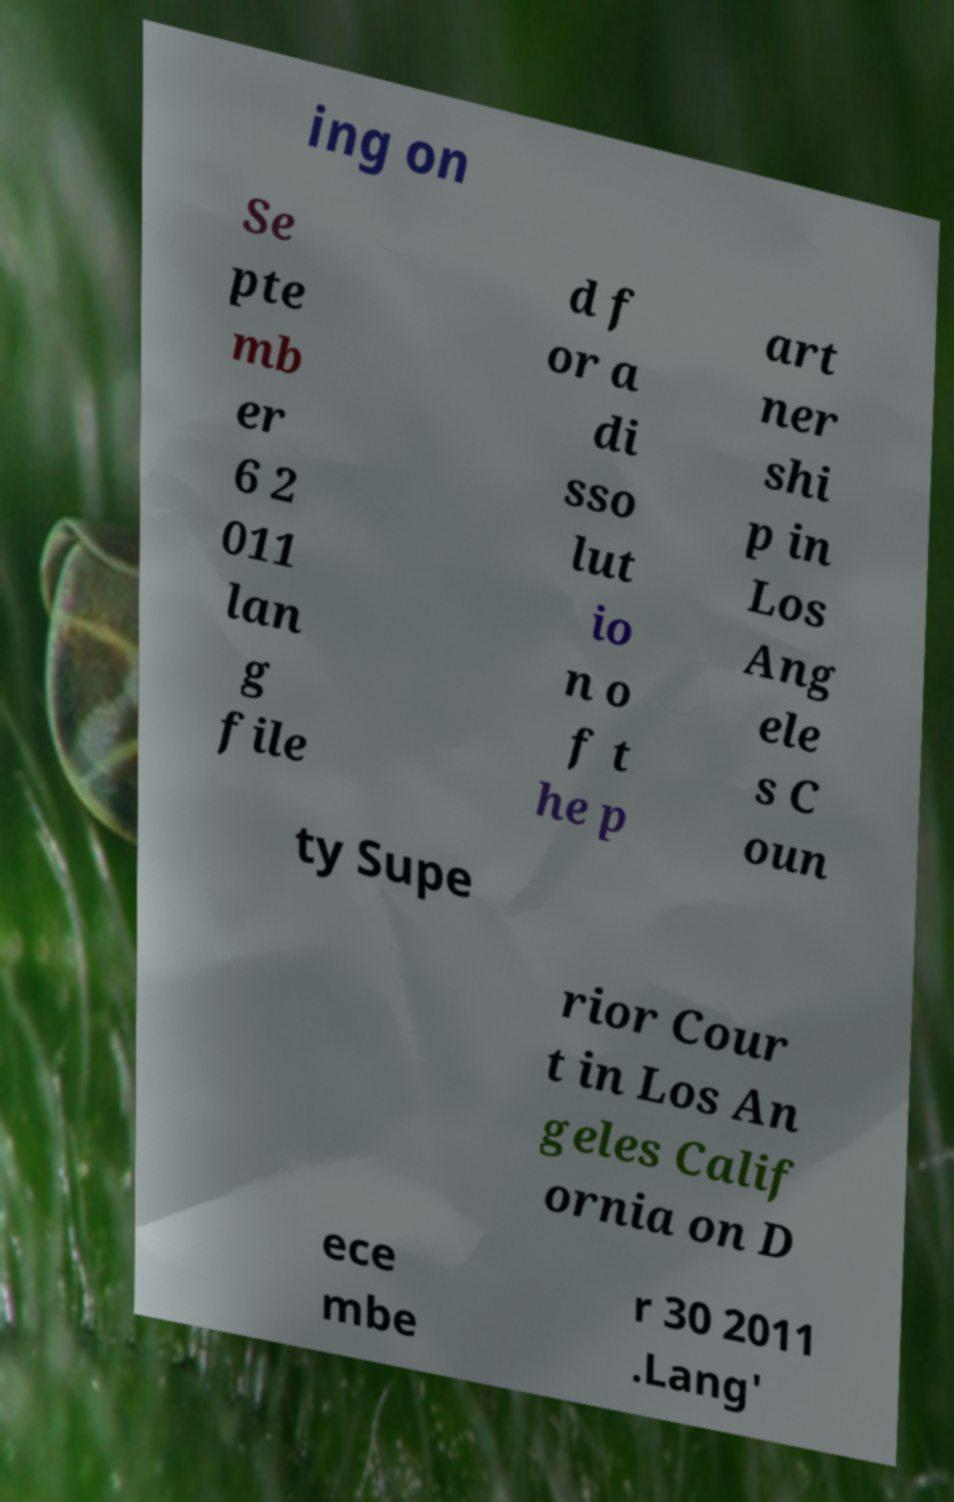Please read and relay the text visible in this image. What does it say? ing on Se pte mb er 6 2 011 lan g file d f or a di sso lut io n o f t he p art ner shi p in Los Ang ele s C oun ty Supe rior Cour t in Los An geles Calif ornia on D ece mbe r 30 2011 .Lang' 